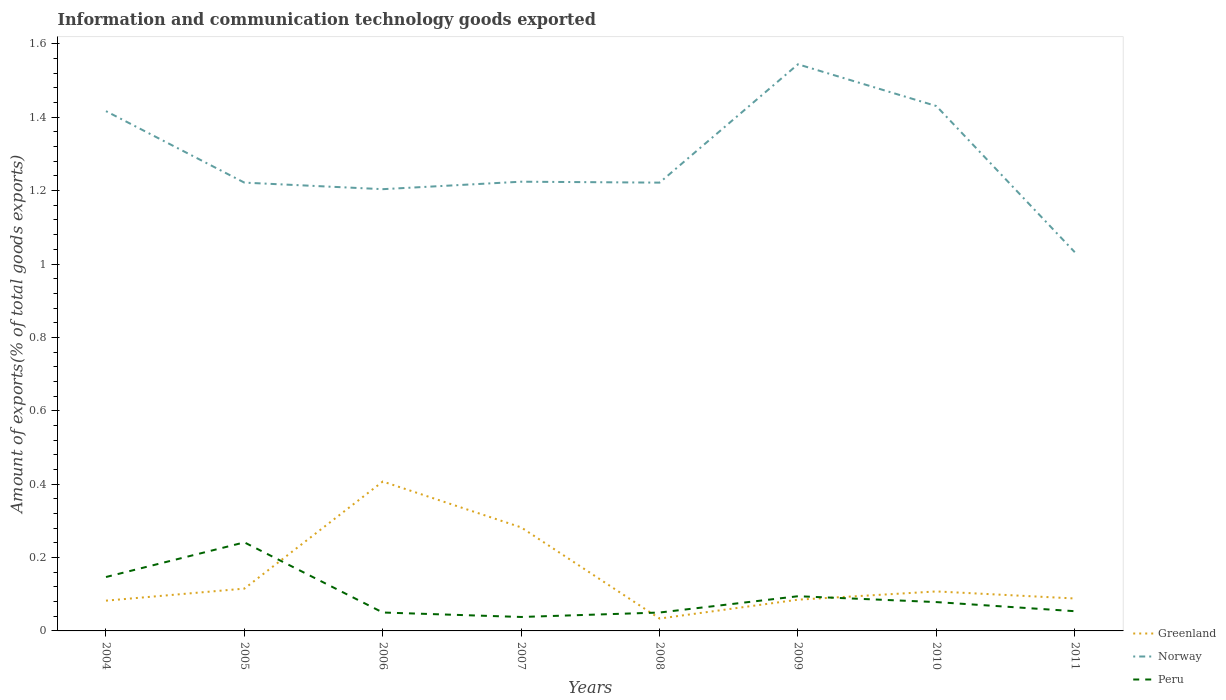How many different coloured lines are there?
Make the answer very short. 3. Is the number of lines equal to the number of legend labels?
Your response must be concise. Yes. Across all years, what is the maximum amount of goods exported in Norway?
Your answer should be very brief. 1.03. In which year was the amount of goods exported in Peru maximum?
Keep it short and to the point. 2007. What is the total amount of goods exported in Peru in the graph?
Ensure brevity in your answer.  0.16. What is the difference between the highest and the second highest amount of goods exported in Peru?
Your response must be concise. 0.2. What is the difference between the highest and the lowest amount of goods exported in Norway?
Provide a short and direct response. 3. Is the amount of goods exported in Greenland strictly greater than the amount of goods exported in Peru over the years?
Your answer should be compact. No. How many lines are there?
Provide a succinct answer. 3. What is the difference between two consecutive major ticks on the Y-axis?
Offer a terse response. 0.2. Are the values on the major ticks of Y-axis written in scientific E-notation?
Offer a terse response. No. Does the graph contain any zero values?
Ensure brevity in your answer.  No. Does the graph contain grids?
Provide a short and direct response. No. Where does the legend appear in the graph?
Your response must be concise. Bottom right. How many legend labels are there?
Offer a terse response. 3. How are the legend labels stacked?
Give a very brief answer. Vertical. What is the title of the graph?
Your response must be concise. Information and communication technology goods exported. What is the label or title of the X-axis?
Make the answer very short. Years. What is the label or title of the Y-axis?
Make the answer very short. Amount of exports(% of total goods exports). What is the Amount of exports(% of total goods exports) of Greenland in 2004?
Give a very brief answer. 0.08. What is the Amount of exports(% of total goods exports) of Norway in 2004?
Give a very brief answer. 1.42. What is the Amount of exports(% of total goods exports) in Peru in 2004?
Provide a short and direct response. 0.15. What is the Amount of exports(% of total goods exports) in Greenland in 2005?
Keep it short and to the point. 0.12. What is the Amount of exports(% of total goods exports) of Norway in 2005?
Keep it short and to the point. 1.22. What is the Amount of exports(% of total goods exports) in Peru in 2005?
Provide a short and direct response. 0.24. What is the Amount of exports(% of total goods exports) of Greenland in 2006?
Your response must be concise. 0.41. What is the Amount of exports(% of total goods exports) of Norway in 2006?
Make the answer very short. 1.2. What is the Amount of exports(% of total goods exports) in Peru in 2006?
Make the answer very short. 0.05. What is the Amount of exports(% of total goods exports) of Greenland in 2007?
Offer a very short reply. 0.28. What is the Amount of exports(% of total goods exports) of Norway in 2007?
Give a very brief answer. 1.22. What is the Amount of exports(% of total goods exports) in Peru in 2007?
Your response must be concise. 0.04. What is the Amount of exports(% of total goods exports) in Greenland in 2008?
Provide a succinct answer. 0.03. What is the Amount of exports(% of total goods exports) in Norway in 2008?
Offer a very short reply. 1.22. What is the Amount of exports(% of total goods exports) of Peru in 2008?
Offer a terse response. 0.05. What is the Amount of exports(% of total goods exports) in Greenland in 2009?
Give a very brief answer. 0.09. What is the Amount of exports(% of total goods exports) in Norway in 2009?
Your response must be concise. 1.54. What is the Amount of exports(% of total goods exports) of Peru in 2009?
Your answer should be compact. 0.09. What is the Amount of exports(% of total goods exports) of Greenland in 2010?
Provide a short and direct response. 0.11. What is the Amount of exports(% of total goods exports) in Norway in 2010?
Your answer should be compact. 1.43. What is the Amount of exports(% of total goods exports) of Peru in 2010?
Give a very brief answer. 0.08. What is the Amount of exports(% of total goods exports) of Greenland in 2011?
Provide a succinct answer. 0.09. What is the Amount of exports(% of total goods exports) of Norway in 2011?
Offer a very short reply. 1.03. What is the Amount of exports(% of total goods exports) in Peru in 2011?
Your answer should be very brief. 0.05. Across all years, what is the maximum Amount of exports(% of total goods exports) of Greenland?
Keep it short and to the point. 0.41. Across all years, what is the maximum Amount of exports(% of total goods exports) of Norway?
Your answer should be compact. 1.54. Across all years, what is the maximum Amount of exports(% of total goods exports) of Peru?
Offer a very short reply. 0.24. Across all years, what is the minimum Amount of exports(% of total goods exports) of Greenland?
Offer a very short reply. 0.03. Across all years, what is the minimum Amount of exports(% of total goods exports) of Norway?
Make the answer very short. 1.03. Across all years, what is the minimum Amount of exports(% of total goods exports) in Peru?
Provide a succinct answer. 0.04. What is the total Amount of exports(% of total goods exports) in Greenland in the graph?
Your response must be concise. 1.2. What is the total Amount of exports(% of total goods exports) of Norway in the graph?
Offer a terse response. 10.3. What is the total Amount of exports(% of total goods exports) in Peru in the graph?
Your answer should be very brief. 0.75. What is the difference between the Amount of exports(% of total goods exports) in Greenland in 2004 and that in 2005?
Keep it short and to the point. -0.03. What is the difference between the Amount of exports(% of total goods exports) in Norway in 2004 and that in 2005?
Give a very brief answer. 0.19. What is the difference between the Amount of exports(% of total goods exports) of Peru in 2004 and that in 2005?
Make the answer very short. -0.09. What is the difference between the Amount of exports(% of total goods exports) in Greenland in 2004 and that in 2006?
Your response must be concise. -0.32. What is the difference between the Amount of exports(% of total goods exports) in Norway in 2004 and that in 2006?
Your response must be concise. 0.21. What is the difference between the Amount of exports(% of total goods exports) of Peru in 2004 and that in 2006?
Give a very brief answer. 0.1. What is the difference between the Amount of exports(% of total goods exports) in Greenland in 2004 and that in 2007?
Your answer should be compact. -0.2. What is the difference between the Amount of exports(% of total goods exports) in Norway in 2004 and that in 2007?
Your answer should be very brief. 0.19. What is the difference between the Amount of exports(% of total goods exports) in Peru in 2004 and that in 2007?
Provide a succinct answer. 0.11. What is the difference between the Amount of exports(% of total goods exports) in Greenland in 2004 and that in 2008?
Your answer should be compact. 0.05. What is the difference between the Amount of exports(% of total goods exports) in Norway in 2004 and that in 2008?
Offer a very short reply. 0.19. What is the difference between the Amount of exports(% of total goods exports) in Peru in 2004 and that in 2008?
Your answer should be compact. 0.1. What is the difference between the Amount of exports(% of total goods exports) in Greenland in 2004 and that in 2009?
Your answer should be very brief. -0. What is the difference between the Amount of exports(% of total goods exports) in Norway in 2004 and that in 2009?
Your answer should be compact. -0.13. What is the difference between the Amount of exports(% of total goods exports) in Peru in 2004 and that in 2009?
Your answer should be very brief. 0.05. What is the difference between the Amount of exports(% of total goods exports) of Greenland in 2004 and that in 2010?
Keep it short and to the point. -0.03. What is the difference between the Amount of exports(% of total goods exports) of Norway in 2004 and that in 2010?
Give a very brief answer. -0.01. What is the difference between the Amount of exports(% of total goods exports) of Peru in 2004 and that in 2010?
Your answer should be very brief. 0.07. What is the difference between the Amount of exports(% of total goods exports) of Greenland in 2004 and that in 2011?
Your answer should be compact. -0.01. What is the difference between the Amount of exports(% of total goods exports) in Norway in 2004 and that in 2011?
Provide a short and direct response. 0.38. What is the difference between the Amount of exports(% of total goods exports) of Peru in 2004 and that in 2011?
Offer a very short reply. 0.09. What is the difference between the Amount of exports(% of total goods exports) in Greenland in 2005 and that in 2006?
Your response must be concise. -0.29. What is the difference between the Amount of exports(% of total goods exports) in Norway in 2005 and that in 2006?
Keep it short and to the point. 0.02. What is the difference between the Amount of exports(% of total goods exports) of Peru in 2005 and that in 2006?
Provide a short and direct response. 0.19. What is the difference between the Amount of exports(% of total goods exports) of Greenland in 2005 and that in 2007?
Your response must be concise. -0.17. What is the difference between the Amount of exports(% of total goods exports) in Norway in 2005 and that in 2007?
Your answer should be compact. -0. What is the difference between the Amount of exports(% of total goods exports) in Peru in 2005 and that in 2007?
Keep it short and to the point. 0.2. What is the difference between the Amount of exports(% of total goods exports) in Greenland in 2005 and that in 2008?
Your response must be concise. 0.08. What is the difference between the Amount of exports(% of total goods exports) of Peru in 2005 and that in 2008?
Provide a succinct answer. 0.19. What is the difference between the Amount of exports(% of total goods exports) in Greenland in 2005 and that in 2009?
Provide a short and direct response. 0.03. What is the difference between the Amount of exports(% of total goods exports) of Norway in 2005 and that in 2009?
Provide a short and direct response. -0.32. What is the difference between the Amount of exports(% of total goods exports) of Peru in 2005 and that in 2009?
Your response must be concise. 0.15. What is the difference between the Amount of exports(% of total goods exports) of Greenland in 2005 and that in 2010?
Ensure brevity in your answer.  0.01. What is the difference between the Amount of exports(% of total goods exports) in Norway in 2005 and that in 2010?
Your answer should be compact. -0.21. What is the difference between the Amount of exports(% of total goods exports) of Peru in 2005 and that in 2010?
Your answer should be compact. 0.16. What is the difference between the Amount of exports(% of total goods exports) of Greenland in 2005 and that in 2011?
Give a very brief answer. 0.03. What is the difference between the Amount of exports(% of total goods exports) in Norway in 2005 and that in 2011?
Ensure brevity in your answer.  0.19. What is the difference between the Amount of exports(% of total goods exports) in Peru in 2005 and that in 2011?
Keep it short and to the point. 0.19. What is the difference between the Amount of exports(% of total goods exports) of Greenland in 2006 and that in 2007?
Your response must be concise. 0.12. What is the difference between the Amount of exports(% of total goods exports) of Norway in 2006 and that in 2007?
Give a very brief answer. -0.02. What is the difference between the Amount of exports(% of total goods exports) in Peru in 2006 and that in 2007?
Keep it short and to the point. 0.01. What is the difference between the Amount of exports(% of total goods exports) of Greenland in 2006 and that in 2008?
Your answer should be very brief. 0.37. What is the difference between the Amount of exports(% of total goods exports) in Norway in 2006 and that in 2008?
Offer a terse response. -0.02. What is the difference between the Amount of exports(% of total goods exports) in Greenland in 2006 and that in 2009?
Keep it short and to the point. 0.32. What is the difference between the Amount of exports(% of total goods exports) in Norway in 2006 and that in 2009?
Provide a succinct answer. -0.34. What is the difference between the Amount of exports(% of total goods exports) of Peru in 2006 and that in 2009?
Your answer should be compact. -0.04. What is the difference between the Amount of exports(% of total goods exports) of Greenland in 2006 and that in 2010?
Provide a succinct answer. 0.3. What is the difference between the Amount of exports(% of total goods exports) in Norway in 2006 and that in 2010?
Make the answer very short. -0.23. What is the difference between the Amount of exports(% of total goods exports) in Peru in 2006 and that in 2010?
Give a very brief answer. -0.03. What is the difference between the Amount of exports(% of total goods exports) of Greenland in 2006 and that in 2011?
Make the answer very short. 0.32. What is the difference between the Amount of exports(% of total goods exports) of Norway in 2006 and that in 2011?
Keep it short and to the point. 0.17. What is the difference between the Amount of exports(% of total goods exports) of Peru in 2006 and that in 2011?
Offer a terse response. -0. What is the difference between the Amount of exports(% of total goods exports) in Greenland in 2007 and that in 2008?
Your response must be concise. 0.25. What is the difference between the Amount of exports(% of total goods exports) of Norway in 2007 and that in 2008?
Provide a short and direct response. 0. What is the difference between the Amount of exports(% of total goods exports) of Peru in 2007 and that in 2008?
Make the answer very short. -0.01. What is the difference between the Amount of exports(% of total goods exports) of Greenland in 2007 and that in 2009?
Provide a short and direct response. 0.2. What is the difference between the Amount of exports(% of total goods exports) in Norway in 2007 and that in 2009?
Keep it short and to the point. -0.32. What is the difference between the Amount of exports(% of total goods exports) of Peru in 2007 and that in 2009?
Ensure brevity in your answer.  -0.06. What is the difference between the Amount of exports(% of total goods exports) in Greenland in 2007 and that in 2010?
Your answer should be very brief. 0.17. What is the difference between the Amount of exports(% of total goods exports) of Norway in 2007 and that in 2010?
Ensure brevity in your answer.  -0.21. What is the difference between the Amount of exports(% of total goods exports) in Peru in 2007 and that in 2010?
Provide a short and direct response. -0.04. What is the difference between the Amount of exports(% of total goods exports) in Greenland in 2007 and that in 2011?
Your response must be concise. 0.19. What is the difference between the Amount of exports(% of total goods exports) in Norway in 2007 and that in 2011?
Your answer should be very brief. 0.19. What is the difference between the Amount of exports(% of total goods exports) in Peru in 2007 and that in 2011?
Offer a very short reply. -0.02. What is the difference between the Amount of exports(% of total goods exports) in Greenland in 2008 and that in 2009?
Your response must be concise. -0.05. What is the difference between the Amount of exports(% of total goods exports) of Norway in 2008 and that in 2009?
Provide a succinct answer. -0.32. What is the difference between the Amount of exports(% of total goods exports) of Peru in 2008 and that in 2009?
Ensure brevity in your answer.  -0.04. What is the difference between the Amount of exports(% of total goods exports) in Greenland in 2008 and that in 2010?
Provide a succinct answer. -0.07. What is the difference between the Amount of exports(% of total goods exports) in Norway in 2008 and that in 2010?
Ensure brevity in your answer.  -0.21. What is the difference between the Amount of exports(% of total goods exports) in Peru in 2008 and that in 2010?
Your answer should be compact. -0.03. What is the difference between the Amount of exports(% of total goods exports) in Greenland in 2008 and that in 2011?
Keep it short and to the point. -0.05. What is the difference between the Amount of exports(% of total goods exports) of Norway in 2008 and that in 2011?
Make the answer very short. 0.19. What is the difference between the Amount of exports(% of total goods exports) of Peru in 2008 and that in 2011?
Ensure brevity in your answer.  -0. What is the difference between the Amount of exports(% of total goods exports) in Greenland in 2009 and that in 2010?
Your answer should be very brief. -0.02. What is the difference between the Amount of exports(% of total goods exports) in Norway in 2009 and that in 2010?
Ensure brevity in your answer.  0.11. What is the difference between the Amount of exports(% of total goods exports) of Peru in 2009 and that in 2010?
Offer a terse response. 0.02. What is the difference between the Amount of exports(% of total goods exports) in Greenland in 2009 and that in 2011?
Your answer should be very brief. -0. What is the difference between the Amount of exports(% of total goods exports) in Norway in 2009 and that in 2011?
Give a very brief answer. 0.51. What is the difference between the Amount of exports(% of total goods exports) of Peru in 2009 and that in 2011?
Offer a very short reply. 0.04. What is the difference between the Amount of exports(% of total goods exports) of Greenland in 2010 and that in 2011?
Your response must be concise. 0.02. What is the difference between the Amount of exports(% of total goods exports) of Norway in 2010 and that in 2011?
Your answer should be very brief. 0.4. What is the difference between the Amount of exports(% of total goods exports) in Peru in 2010 and that in 2011?
Your answer should be compact. 0.02. What is the difference between the Amount of exports(% of total goods exports) of Greenland in 2004 and the Amount of exports(% of total goods exports) of Norway in 2005?
Keep it short and to the point. -1.14. What is the difference between the Amount of exports(% of total goods exports) in Greenland in 2004 and the Amount of exports(% of total goods exports) in Peru in 2005?
Provide a succinct answer. -0.16. What is the difference between the Amount of exports(% of total goods exports) of Norway in 2004 and the Amount of exports(% of total goods exports) of Peru in 2005?
Give a very brief answer. 1.18. What is the difference between the Amount of exports(% of total goods exports) of Greenland in 2004 and the Amount of exports(% of total goods exports) of Norway in 2006?
Offer a very short reply. -1.12. What is the difference between the Amount of exports(% of total goods exports) in Greenland in 2004 and the Amount of exports(% of total goods exports) in Peru in 2006?
Your answer should be very brief. 0.03. What is the difference between the Amount of exports(% of total goods exports) in Norway in 2004 and the Amount of exports(% of total goods exports) in Peru in 2006?
Make the answer very short. 1.37. What is the difference between the Amount of exports(% of total goods exports) in Greenland in 2004 and the Amount of exports(% of total goods exports) in Norway in 2007?
Offer a very short reply. -1.14. What is the difference between the Amount of exports(% of total goods exports) in Greenland in 2004 and the Amount of exports(% of total goods exports) in Peru in 2007?
Provide a short and direct response. 0.04. What is the difference between the Amount of exports(% of total goods exports) of Norway in 2004 and the Amount of exports(% of total goods exports) of Peru in 2007?
Your response must be concise. 1.38. What is the difference between the Amount of exports(% of total goods exports) in Greenland in 2004 and the Amount of exports(% of total goods exports) in Norway in 2008?
Give a very brief answer. -1.14. What is the difference between the Amount of exports(% of total goods exports) in Greenland in 2004 and the Amount of exports(% of total goods exports) in Peru in 2008?
Provide a succinct answer. 0.03. What is the difference between the Amount of exports(% of total goods exports) in Norway in 2004 and the Amount of exports(% of total goods exports) in Peru in 2008?
Keep it short and to the point. 1.37. What is the difference between the Amount of exports(% of total goods exports) of Greenland in 2004 and the Amount of exports(% of total goods exports) of Norway in 2009?
Make the answer very short. -1.46. What is the difference between the Amount of exports(% of total goods exports) of Greenland in 2004 and the Amount of exports(% of total goods exports) of Peru in 2009?
Make the answer very short. -0.01. What is the difference between the Amount of exports(% of total goods exports) of Norway in 2004 and the Amount of exports(% of total goods exports) of Peru in 2009?
Provide a short and direct response. 1.32. What is the difference between the Amount of exports(% of total goods exports) in Greenland in 2004 and the Amount of exports(% of total goods exports) in Norway in 2010?
Your response must be concise. -1.35. What is the difference between the Amount of exports(% of total goods exports) in Greenland in 2004 and the Amount of exports(% of total goods exports) in Peru in 2010?
Keep it short and to the point. 0. What is the difference between the Amount of exports(% of total goods exports) in Norway in 2004 and the Amount of exports(% of total goods exports) in Peru in 2010?
Give a very brief answer. 1.34. What is the difference between the Amount of exports(% of total goods exports) of Greenland in 2004 and the Amount of exports(% of total goods exports) of Norway in 2011?
Make the answer very short. -0.95. What is the difference between the Amount of exports(% of total goods exports) in Greenland in 2004 and the Amount of exports(% of total goods exports) in Peru in 2011?
Your response must be concise. 0.03. What is the difference between the Amount of exports(% of total goods exports) in Norway in 2004 and the Amount of exports(% of total goods exports) in Peru in 2011?
Offer a very short reply. 1.36. What is the difference between the Amount of exports(% of total goods exports) of Greenland in 2005 and the Amount of exports(% of total goods exports) of Norway in 2006?
Provide a succinct answer. -1.09. What is the difference between the Amount of exports(% of total goods exports) of Greenland in 2005 and the Amount of exports(% of total goods exports) of Peru in 2006?
Offer a terse response. 0.07. What is the difference between the Amount of exports(% of total goods exports) of Norway in 2005 and the Amount of exports(% of total goods exports) of Peru in 2006?
Offer a very short reply. 1.17. What is the difference between the Amount of exports(% of total goods exports) of Greenland in 2005 and the Amount of exports(% of total goods exports) of Norway in 2007?
Offer a terse response. -1.11. What is the difference between the Amount of exports(% of total goods exports) in Greenland in 2005 and the Amount of exports(% of total goods exports) in Peru in 2007?
Provide a succinct answer. 0.08. What is the difference between the Amount of exports(% of total goods exports) in Norway in 2005 and the Amount of exports(% of total goods exports) in Peru in 2007?
Your answer should be compact. 1.18. What is the difference between the Amount of exports(% of total goods exports) in Greenland in 2005 and the Amount of exports(% of total goods exports) in Norway in 2008?
Your answer should be compact. -1.11. What is the difference between the Amount of exports(% of total goods exports) in Greenland in 2005 and the Amount of exports(% of total goods exports) in Peru in 2008?
Your answer should be compact. 0.07. What is the difference between the Amount of exports(% of total goods exports) of Norway in 2005 and the Amount of exports(% of total goods exports) of Peru in 2008?
Your answer should be very brief. 1.17. What is the difference between the Amount of exports(% of total goods exports) of Greenland in 2005 and the Amount of exports(% of total goods exports) of Norway in 2009?
Offer a terse response. -1.43. What is the difference between the Amount of exports(% of total goods exports) of Greenland in 2005 and the Amount of exports(% of total goods exports) of Peru in 2009?
Keep it short and to the point. 0.02. What is the difference between the Amount of exports(% of total goods exports) of Norway in 2005 and the Amount of exports(% of total goods exports) of Peru in 2009?
Make the answer very short. 1.13. What is the difference between the Amount of exports(% of total goods exports) of Greenland in 2005 and the Amount of exports(% of total goods exports) of Norway in 2010?
Keep it short and to the point. -1.32. What is the difference between the Amount of exports(% of total goods exports) of Greenland in 2005 and the Amount of exports(% of total goods exports) of Peru in 2010?
Give a very brief answer. 0.04. What is the difference between the Amount of exports(% of total goods exports) of Norway in 2005 and the Amount of exports(% of total goods exports) of Peru in 2010?
Your answer should be compact. 1.14. What is the difference between the Amount of exports(% of total goods exports) in Greenland in 2005 and the Amount of exports(% of total goods exports) in Norway in 2011?
Provide a short and direct response. -0.92. What is the difference between the Amount of exports(% of total goods exports) of Greenland in 2005 and the Amount of exports(% of total goods exports) of Peru in 2011?
Provide a short and direct response. 0.06. What is the difference between the Amount of exports(% of total goods exports) in Norway in 2005 and the Amount of exports(% of total goods exports) in Peru in 2011?
Your response must be concise. 1.17. What is the difference between the Amount of exports(% of total goods exports) of Greenland in 2006 and the Amount of exports(% of total goods exports) of Norway in 2007?
Make the answer very short. -0.82. What is the difference between the Amount of exports(% of total goods exports) of Greenland in 2006 and the Amount of exports(% of total goods exports) of Peru in 2007?
Your answer should be very brief. 0.37. What is the difference between the Amount of exports(% of total goods exports) in Norway in 2006 and the Amount of exports(% of total goods exports) in Peru in 2007?
Offer a terse response. 1.17. What is the difference between the Amount of exports(% of total goods exports) in Greenland in 2006 and the Amount of exports(% of total goods exports) in Norway in 2008?
Offer a very short reply. -0.81. What is the difference between the Amount of exports(% of total goods exports) of Greenland in 2006 and the Amount of exports(% of total goods exports) of Peru in 2008?
Provide a short and direct response. 0.36. What is the difference between the Amount of exports(% of total goods exports) in Norway in 2006 and the Amount of exports(% of total goods exports) in Peru in 2008?
Your answer should be very brief. 1.15. What is the difference between the Amount of exports(% of total goods exports) in Greenland in 2006 and the Amount of exports(% of total goods exports) in Norway in 2009?
Give a very brief answer. -1.14. What is the difference between the Amount of exports(% of total goods exports) of Greenland in 2006 and the Amount of exports(% of total goods exports) of Peru in 2009?
Your answer should be compact. 0.31. What is the difference between the Amount of exports(% of total goods exports) of Norway in 2006 and the Amount of exports(% of total goods exports) of Peru in 2009?
Offer a very short reply. 1.11. What is the difference between the Amount of exports(% of total goods exports) of Greenland in 2006 and the Amount of exports(% of total goods exports) of Norway in 2010?
Your response must be concise. -1.02. What is the difference between the Amount of exports(% of total goods exports) in Greenland in 2006 and the Amount of exports(% of total goods exports) in Peru in 2010?
Provide a succinct answer. 0.33. What is the difference between the Amount of exports(% of total goods exports) in Norway in 2006 and the Amount of exports(% of total goods exports) in Peru in 2010?
Keep it short and to the point. 1.13. What is the difference between the Amount of exports(% of total goods exports) of Greenland in 2006 and the Amount of exports(% of total goods exports) of Norway in 2011?
Ensure brevity in your answer.  -0.62. What is the difference between the Amount of exports(% of total goods exports) of Greenland in 2006 and the Amount of exports(% of total goods exports) of Peru in 2011?
Offer a terse response. 0.35. What is the difference between the Amount of exports(% of total goods exports) in Norway in 2006 and the Amount of exports(% of total goods exports) in Peru in 2011?
Your answer should be compact. 1.15. What is the difference between the Amount of exports(% of total goods exports) of Greenland in 2007 and the Amount of exports(% of total goods exports) of Norway in 2008?
Make the answer very short. -0.94. What is the difference between the Amount of exports(% of total goods exports) of Greenland in 2007 and the Amount of exports(% of total goods exports) of Peru in 2008?
Keep it short and to the point. 0.23. What is the difference between the Amount of exports(% of total goods exports) of Norway in 2007 and the Amount of exports(% of total goods exports) of Peru in 2008?
Ensure brevity in your answer.  1.17. What is the difference between the Amount of exports(% of total goods exports) of Greenland in 2007 and the Amount of exports(% of total goods exports) of Norway in 2009?
Offer a terse response. -1.26. What is the difference between the Amount of exports(% of total goods exports) in Greenland in 2007 and the Amount of exports(% of total goods exports) in Peru in 2009?
Provide a succinct answer. 0.19. What is the difference between the Amount of exports(% of total goods exports) of Norway in 2007 and the Amount of exports(% of total goods exports) of Peru in 2009?
Your answer should be compact. 1.13. What is the difference between the Amount of exports(% of total goods exports) of Greenland in 2007 and the Amount of exports(% of total goods exports) of Norway in 2010?
Give a very brief answer. -1.15. What is the difference between the Amount of exports(% of total goods exports) in Greenland in 2007 and the Amount of exports(% of total goods exports) in Peru in 2010?
Give a very brief answer. 0.2. What is the difference between the Amount of exports(% of total goods exports) of Norway in 2007 and the Amount of exports(% of total goods exports) of Peru in 2010?
Offer a terse response. 1.15. What is the difference between the Amount of exports(% of total goods exports) of Greenland in 2007 and the Amount of exports(% of total goods exports) of Norway in 2011?
Make the answer very short. -0.75. What is the difference between the Amount of exports(% of total goods exports) of Greenland in 2007 and the Amount of exports(% of total goods exports) of Peru in 2011?
Your response must be concise. 0.23. What is the difference between the Amount of exports(% of total goods exports) in Norway in 2007 and the Amount of exports(% of total goods exports) in Peru in 2011?
Give a very brief answer. 1.17. What is the difference between the Amount of exports(% of total goods exports) of Greenland in 2008 and the Amount of exports(% of total goods exports) of Norway in 2009?
Make the answer very short. -1.51. What is the difference between the Amount of exports(% of total goods exports) of Greenland in 2008 and the Amount of exports(% of total goods exports) of Peru in 2009?
Keep it short and to the point. -0.06. What is the difference between the Amount of exports(% of total goods exports) of Norway in 2008 and the Amount of exports(% of total goods exports) of Peru in 2009?
Offer a very short reply. 1.13. What is the difference between the Amount of exports(% of total goods exports) of Greenland in 2008 and the Amount of exports(% of total goods exports) of Norway in 2010?
Make the answer very short. -1.4. What is the difference between the Amount of exports(% of total goods exports) of Greenland in 2008 and the Amount of exports(% of total goods exports) of Peru in 2010?
Make the answer very short. -0.04. What is the difference between the Amount of exports(% of total goods exports) of Norway in 2008 and the Amount of exports(% of total goods exports) of Peru in 2010?
Keep it short and to the point. 1.14. What is the difference between the Amount of exports(% of total goods exports) in Greenland in 2008 and the Amount of exports(% of total goods exports) in Norway in 2011?
Make the answer very short. -1. What is the difference between the Amount of exports(% of total goods exports) of Greenland in 2008 and the Amount of exports(% of total goods exports) of Peru in 2011?
Your answer should be very brief. -0.02. What is the difference between the Amount of exports(% of total goods exports) of Norway in 2008 and the Amount of exports(% of total goods exports) of Peru in 2011?
Your response must be concise. 1.17. What is the difference between the Amount of exports(% of total goods exports) in Greenland in 2009 and the Amount of exports(% of total goods exports) in Norway in 2010?
Ensure brevity in your answer.  -1.35. What is the difference between the Amount of exports(% of total goods exports) in Greenland in 2009 and the Amount of exports(% of total goods exports) in Peru in 2010?
Offer a terse response. 0.01. What is the difference between the Amount of exports(% of total goods exports) in Norway in 2009 and the Amount of exports(% of total goods exports) in Peru in 2010?
Provide a succinct answer. 1.47. What is the difference between the Amount of exports(% of total goods exports) in Greenland in 2009 and the Amount of exports(% of total goods exports) in Norway in 2011?
Provide a succinct answer. -0.95. What is the difference between the Amount of exports(% of total goods exports) in Greenland in 2009 and the Amount of exports(% of total goods exports) in Peru in 2011?
Provide a succinct answer. 0.03. What is the difference between the Amount of exports(% of total goods exports) of Norway in 2009 and the Amount of exports(% of total goods exports) of Peru in 2011?
Make the answer very short. 1.49. What is the difference between the Amount of exports(% of total goods exports) of Greenland in 2010 and the Amount of exports(% of total goods exports) of Norway in 2011?
Offer a very short reply. -0.92. What is the difference between the Amount of exports(% of total goods exports) in Greenland in 2010 and the Amount of exports(% of total goods exports) in Peru in 2011?
Give a very brief answer. 0.05. What is the difference between the Amount of exports(% of total goods exports) in Norway in 2010 and the Amount of exports(% of total goods exports) in Peru in 2011?
Provide a short and direct response. 1.38. What is the average Amount of exports(% of total goods exports) of Greenland per year?
Your answer should be very brief. 0.15. What is the average Amount of exports(% of total goods exports) of Norway per year?
Offer a very short reply. 1.29. What is the average Amount of exports(% of total goods exports) in Peru per year?
Your response must be concise. 0.09. In the year 2004, what is the difference between the Amount of exports(% of total goods exports) of Greenland and Amount of exports(% of total goods exports) of Norway?
Provide a succinct answer. -1.33. In the year 2004, what is the difference between the Amount of exports(% of total goods exports) of Greenland and Amount of exports(% of total goods exports) of Peru?
Your response must be concise. -0.06. In the year 2004, what is the difference between the Amount of exports(% of total goods exports) of Norway and Amount of exports(% of total goods exports) of Peru?
Your answer should be very brief. 1.27. In the year 2005, what is the difference between the Amount of exports(% of total goods exports) in Greenland and Amount of exports(% of total goods exports) in Norway?
Your answer should be compact. -1.11. In the year 2005, what is the difference between the Amount of exports(% of total goods exports) in Greenland and Amount of exports(% of total goods exports) in Peru?
Offer a terse response. -0.13. In the year 2005, what is the difference between the Amount of exports(% of total goods exports) of Norway and Amount of exports(% of total goods exports) of Peru?
Ensure brevity in your answer.  0.98. In the year 2006, what is the difference between the Amount of exports(% of total goods exports) in Greenland and Amount of exports(% of total goods exports) in Norway?
Ensure brevity in your answer.  -0.8. In the year 2006, what is the difference between the Amount of exports(% of total goods exports) of Greenland and Amount of exports(% of total goods exports) of Peru?
Offer a very short reply. 0.36. In the year 2006, what is the difference between the Amount of exports(% of total goods exports) in Norway and Amount of exports(% of total goods exports) in Peru?
Offer a terse response. 1.15. In the year 2007, what is the difference between the Amount of exports(% of total goods exports) of Greenland and Amount of exports(% of total goods exports) of Norway?
Offer a terse response. -0.94. In the year 2007, what is the difference between the Amount of exports(% of total goods exports) of Greenland and Amount of exports(% of total goods exports) of Peru?
Provide a succinct answer. 0.24. In the year 2007, what is the difference between the Amount of exports(% of total goods exports) of Norway and Amount of exports(% of total goods exports) of Peru?
Keep it short and to the point. 1.19. In the year 2008, what is the difference between the Amount of exports(% of total goods exports) in Greenland and Amount of exports(% of total goods exports) in Norway?
Offer a very short reply. -1.19. In the year 2008, what is the difference between the Amount of exports(% of total goods exports) of Greenland and Amount of exports(% of total goods exports) of Peru?
Your response must be concise. -0.02. In the year 2008, what is the difference between the Amount of exports(% of total goods exports) in Norway and Amount of exports(% of total goods exports) in Peru?
Provide a succinct answer. 1.17. In the year 2009, what is the difference between the Amount of exports(% of total goods exports) of Greenland and Amount of exports(% of total goods exports) of Norway?
Give a very brief answer. -1.46. In the year 2009, what is the difference between the Amount of exports(% of total goods exports) in Greenland and Amount of exports(% of total goods exports) in Peru?
Ensure brevity in your answer.  -0.01. In the year 2009, what is the difference between the Amount of exports(% of total goods exports) of Norway and Amount of exports(% of total goods exports) of Peru?
Make the answer very short. 1.45. In the year 2010, what is the difference between the Amount of exports(% of total goods exports) in Greenland and Amount of exports(% of total goods exports) in Norway?
Provide a succinct answer. -1.32. In the year 2010, what is the difference between the Amount of exports(% of total goods exports) in Greenland and Amount of exports(% of total goods exports) in Peru?
Your answer should be compact. 0.03. In the year 2010, what is the difference between the Amount of exports(% of total goods exports) of Norway and Amount of exports(% of total goods exports) of Peru?
Provide a short and direct response. 1.35. In the year 2011, what is the difference between the Amount of exports(% of total goods exports) in Greenland and Amount of exports(% of total goods exports) in Norway?
Keep it short and to the point. -0.94. In the year 2011, what is the difference between the Amount of exports(% of total goods exports) in Greenland and Amount of exports(% of total goods exports) in Peru?
Make the answer very short. 0.03. In the year 2011, what is the difference between the Amount of exports(% of total goods exports) of Norway and Amount of exports(% of total goods exports) of Peru?
Provide a succinct answer. 0.98. What is the ratio of the Amount of exports(% of total goods exports) in Greenland in 2004 to that in 2005?
Offer a very short reply. 0.72. What is the ratio of the Amount of exports(% of total goods exports) in Norway in 2004 to that in 2005?
Your response must be concise. 1.16. What is the ratio of the Amount of exports(% of total goods exports) of Peru in 2004 to that in 2005?
Keep it short and to the point. 0.61. What is the ratio of the Amount of exports(% of total goods exports) of Greenland in 2004 to that in 2006?
Provide a succinct answer. 0.2. What is the ratio of the Amount of exports(% of total goods exports) in Norway in 2004 to that in 2006?
Give a very brief answer. 1.18. What is the ratio of the Amount of exports(% of total goods exports) of Peru in 2004 to that in 2006?
Offer a terse response. 2.93. What is the ratio of the Amount of exports(% of total goods exports) of Greenland in 2004 to that in 2007?
Give a very brief answer. 0.29. What is the ratio of the Amount of exports(% of total goods exports) of Norway in 2004 to that in 2007?
Your answer should be compact. 1.16. What is the ratio of the Amount of exports(% of total goods exports) of Peru in 2004 to that in 2007?
Your answer should be compact. 3.86. What is the ratio of the Amount of exports(% of total goods exports) of Greenland in 2004 to that in 2008?
Keep it short and to the point. 2.45. What is the ratio of the Amount of exports(% of total goods exports) of Norway in 2004 to that in 2008?
Keep it short and to the point. 1.16. What is the ratio of the Amount of exports(% of total goods exports) of Peru in 2004 to that in 2008?
Make the answer very short. 2.93. What is the ratio of the Amount of exports(% of total goods exports) of Greenland in 2004 to that in 2009?
Your answer should be compact. 0.97. What is the ratio of the Amount of exports(% of total goods exports) of Norway in 2004 to that in 2009?
Provide a succinct answer. 0.92. What is the ratio of the Amount of exports(% of total goods exports) in Peru in 2004 to that in 2009?
Your response must be concise. 1.55. What is the ratio of the Amount of exports(% of total goods exports) of Greenland in 2004 to that in 2010?
Provide a short and direct response. 0.77. What is the ratio of the Amount of exports(% of total goods exports) of Norway in 2004 to that in 2010?
Provide a succinct answer. 0.99. What is the ratio of the Amount of exports(% of total goods exports) in Peru in 2004 to that in 2010?
Provide a succinct answer. 1.87. What is the ratio of the Amount of exports(% of total goods exports) of Greenland in 2004 to that in 2011?
Keep it short and to the point. 0.93. What is the ratio of the Amount of exports(% of total goods exports) in Norway in 2004 to that in 2011?
Your response must be concise. 1.37. What is the ratio of the Amount of exports(% of total goods exports) in Peru in 2004 to that in 2011?
Ensure brevity in your answer.  2.73. What is the ratio of the Amount of exports(% of total goods exports) in Greenland in 2005 to that in 2006?
Your response must be concise. 0.28. What is the ratio of the Amount of exports(% of total goods exports) in Norway in 2005 to that in 2006?
Your response must be concise. 1.01. What is the ratio of the Amount of exports(% of total goods exports) in Peru in 2005 to that in 2006?
Make the answer very short. 4.81. What is the ratio of the Amount of exports(% of total goods exports) of Greenland in 2005 to that in 2007?
Your answer should be very brief. 0.41. What is the ratio of the Amount of exports(% of total goods exports) in Norway in 2005 to that in 2007?
Ensure brevity in your answer.  1. What is the ratio of the Amount of exports(% of total goods exports) of Peru in 2005 to that in 2007?
Provide a succinct answer. 6.35. What is the ratio of the Amount of exports(% of total goods exports) in Greenland in 2005 to that in 2008?
Keep it short and to the point. 3.42. What is the ratio of the Amount of exports(% of total goods exports) of Peru in 2005 to that in 2008?
Your response must be concise. 4.81. What is the ratio of the Amount of exports(% of total goods exports) of Greenland in 2005 to that in 2009?
Your response must be concise. 1.35. What is the ratio of the Amount of exports(% of total goods exports) of Norway in 2005 to that in 2009?
Your answer should be compact. 0.79. What is the ratio of the Amount of exports(% of total goods exports) of Peru in 2005 to that in 2009?
Your response must be concise. 2.55. What is the ratio of the Amount of exports(% of total goods exports) of Greenland in 2005 to that in 2010?
Provide a succinct answer. 1.07. What is the ratio of the Amount of exports(% of total goods exports) in Norway in 2005 to that in 2010?
Offer a very short reply. 0.85. What is the ratio of the Amount of exports(% of total goods exports) in Peru in 2005 to that in 2010?
Keep it short and to the point. 3.07. What is the ratio of the Amount of exports(% of total goods exports) in Greenland in 2005 to that in 2011?
Offer a very short reply. 1.3. What is the ratio of the Amount of exports(% of total goods exports) in Norway in 2005 to that in 2011?
Give a very brief answer. 1.18. What is the ratio of the Amount of exports(% of total goods exports) in Peru in 2005 to that in 2011?
Your response must be concise. 4.49. What is the ratio of the Amount of exports(% of total goods exports) of Greenland in 2006 to that in 2007?
Make the answer very short. 1.44. What is the ratio of the Amount of exports(% of total goods exports) in Norway in 2006 to that in 2007?
Provide a succinct answer. 0.98. What is the ratio of the Amount of exports(% of total goods exports) of Peru in 2006 to that in 2007?
Give a very brief answer. 1.32. What is the ratio of the Amount of exports(% of total goods exports) in Greenland in 2006 to that in 2008?
Your answer should be compact. 12.08. What is the ratio of the Amount of exports(% of total goods exports) in Norway in 2006 to that in 2008?
Give a very brief answer. 0.99. What is the ratio of the Amount of exports(% of total goods exports) in Greenland in 2006 to that in 2009?
Offer a terse response. 4.78. What is the ratio of the Amount of exports(% of total goods exports) in Norway in 2006 to that in 2009?
Make the answer very short. 0.78. What is the ratio of the Amount of exports(% of total goods exports) of Peru in 2006 to that in 2009?
Your answer should be compact. 0.53. What is the ratio of the Amount of exports(% of total goods exports) in Greenland in 2006 to that in 2010?
Keep it short and to the point. 3.78. What is the ratio of the Amount of exports(% of total goods exports) of Norway in 2006 to that in 2010?
Keep it short and to the point. 0.84. What is the ratio of the Amount of exports(% of total goods exports) in Peru in 2006 to that in 2010?
Your answer should be very brief. 0.64. What is the ratio of the Amount of exports(% of total goods exports) of Greenland in 2006 to that in 2011?
Offer a very short reply. 4.61. What is the ratio of the Amount of exports(% of total goods exports) of Norway in 2006 to that in 2011?
Provide a succinct answer. 1.17. What is the ratio of the Amount of exports(% of total goods exports) in Peru in 2006 to that in 2011?
Keep it short and to the point. 0.93. What is the ratio of the Amount of exports(% of total goods exports) in Greenland in 2007 to that in 2008?
Your answer should be very brief. 8.37. What is the ratio of the Amount of exports(% of total goods exports) in Peru in 2007 to that in 2008?
Your answer should be very brief. 0.76. What is the ratio of the Amount of exports(% of total goods exports) of Greenland in 2007 to that in 2009?
Offer a terse response. 3.31. What is the ratio of the Amount of exports(% of total goods exports) in Norway in 2007 to that in 2009?
Give a very brief answer. 0.79. What is the ratio of the Amount of exports(% of total goods exports) in Peru in 2007 to that in 2009?
Provide a succinct answer. 0.4. What is the ratio of the Amount of exports(% of total goods exports) in Greenland in 2007 to that in 2010?
Offer a very short reply. 2.62. What is the ratio of the Amount of exports(% of total goods exports) of Norway in 2007 to that in 2010?
Keep it short and to the point. 0.86. What is the ratio of the Amount of exports(% of total goods exports) in Peru in 2007 to that in 2010?
Your answer should be very brief. 0.48. What is the ratio of the Amount of exports(% of total goods exports) in Greenland in 2007 to that in 2011?
Provide a succinct answer. 3.19. What is the ratio of the Amount of exports(% of total goods exports) of Norway in 2007 to that in 2011?
Give a very brief answer. 1.19. What is the ratio of the Amount of exports(% of total goods exports) of Peru in 2007 to that in 2011?
Provide a short and direct response. 0.71. What is the ratio of the Amount of exports(% of total goods exports) in Greenland in 2008 to that in 2009?
Give a very brief answer. 0.4. What is the ratio of the Amount of exports(% of total goods exports) of Norway in 2008 to that in 2009?
Give a very brief answer. 0.79. What is the ratio of the Amount of exports(% of total goods exports) in Peru in 2008 to that in 2009?
Give a very brief answer. 0.53. What is the ratio of the Amount of exports(% of total goods exports) in Greenland in 2008 to that in 2010?
Ensure brevity in your answer.  0.31. What is the ratio of the Amount of exports(% of total goods exports) of Norway in 2008 to that in 2010?
Your response must be concise. 0.85. What is the ratio of the Amount of exports(% of total goods exports) in Peru in 2008 to that in 2010?
Offer a terse response. 0.64. What is the ratio of the Amount of exports(% of total goods exports) of Greenland in 2008 to that in 2011?
Provide a succinct answer. 0.38. What is the ratio of the Amount of exports(% of total goods exports) in Norway in 2008 to that in 2011?
Provide a short and direct response. 1.18. What is the ratio of the Amount of exports(% of total goods exports) in Peru in 2008 to that in 2011?
Provide a succinct answer. 0.93. What is the ratio of the Amount of exports(% of total goods exports) of Greenland in 2009 to that in 2010?
Give a very brief answer. 0.79. What is the ratio of the Amount of exports(% of total goods exports) of Norway in 2009 to that in 2010?
Provide a succinct answer. 1.08. What is the ratio of the Amount of exports(% of total goods exports) in Peru in 2009 to that in 2010?
Offer a terse response. 1.2. What is the ratio of the Amount of exports(% of total goods exports) in Greenland in 2009 to that in 2011?
Your answer should be compact. 0.96. What is the ratio of the Amount of exports(% of total goods exports) in Norway in 2009 to that in 2011?
Make the answer very short. 1.5. What is the ratio of the Amount of exports(% of total goods exports) of Peru in 2009 to that in 2011?
Your answer should be compact. 1.76. What is the ratio of the Amount of exports(% of total goods exports) in Greenland in 2010 to that in 2011?
Your response must be concise. 1.22. What is the ratio of the Amount of exports(% of total goods exports) of Norway in 2010 to that in 2011?
Keep it short and to the point. 1.39. What is the ratio of the Amount of exports(% of total goods exports) in Peru in 2010 to that in 2011?
Your answer should be compact. 1.46. What is the difference between the highest and the second highest Amount of exports(% of total goods exports) in Norway?
Provide a succinct answer. 0.11. What is the difference between the highest and the second highest Amount of exports(% of total goods exports) in Peru?
Keep it short and to the point. 0.09. What is the difference between the highest and the lowest Amount of exports(% of total goods exports) in Greenland?
Give a very brief answer. 0.37. What is the difference between the highest and the lowest Amount of exports(% of total goods exports) in Norway?
Your answer should be very brief. 0.51. What is the difference between the highest and the lowest Amount of exports(% of total goods exports) of Peru?
Your response must be concise. 0.2. 